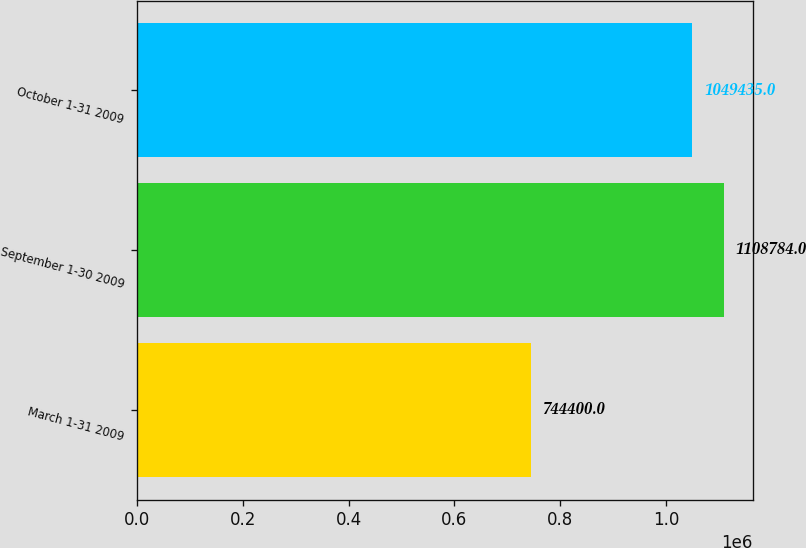<chart> <loc_0><loc_0><loc_500><loc_500><bar_chart><fcel>March 1-31 2009<fcel>September 1-30 2009<fcel>October 1-31 2009<nl><fcel>744400<fcel>1.10878e+06<fcel>1.04944e+06<nl></chart> 